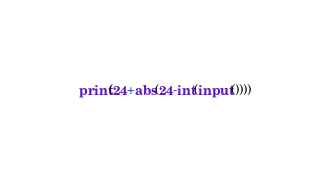Convert code to text. <code><loc_0><loc_0><loc_500><loc_500><_Python_>print(24+abs(24-int(input())))
</code> 